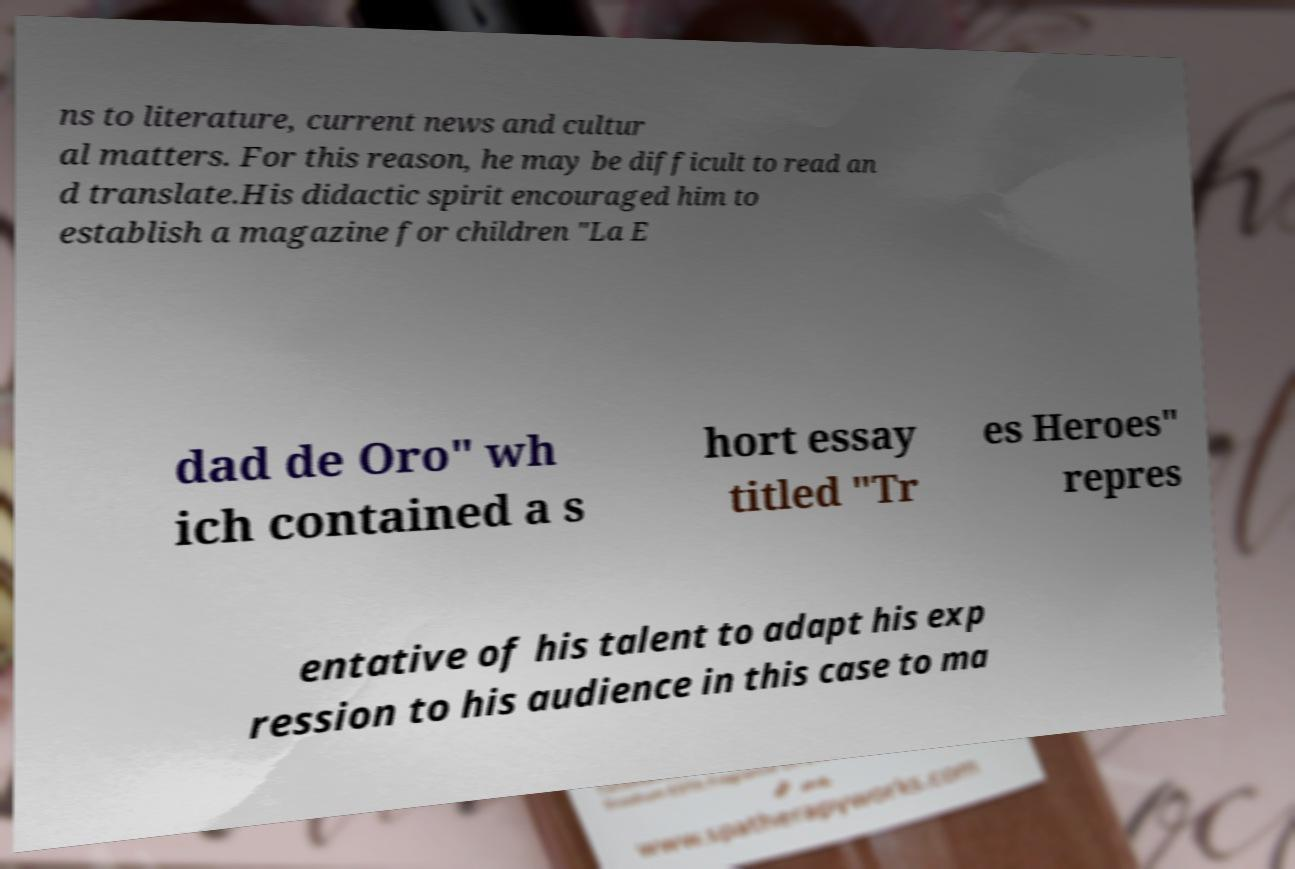Could you extract and type out the text from this image? ns to literature, current news and cultur al matters. For this reason, he may be difficult to read an d translate.His didactic spirit encouraged him to establish a magazine for children "La E dad de Oro" wh ich contained a s hort essay titled "Tr es Heroes" repres entative of his talent to adapt his exp ression to his audience in this case to ma 